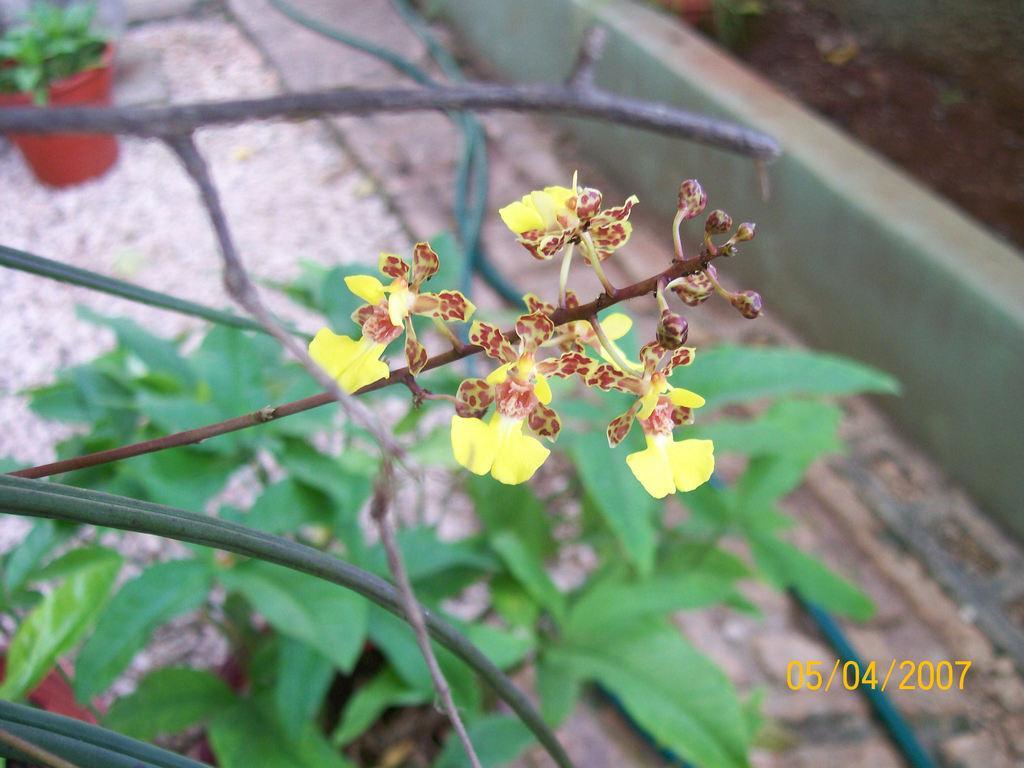Describe this image in one or two sentences. In the center of the image we can see flowers and plants. In the background we can see house plant. 